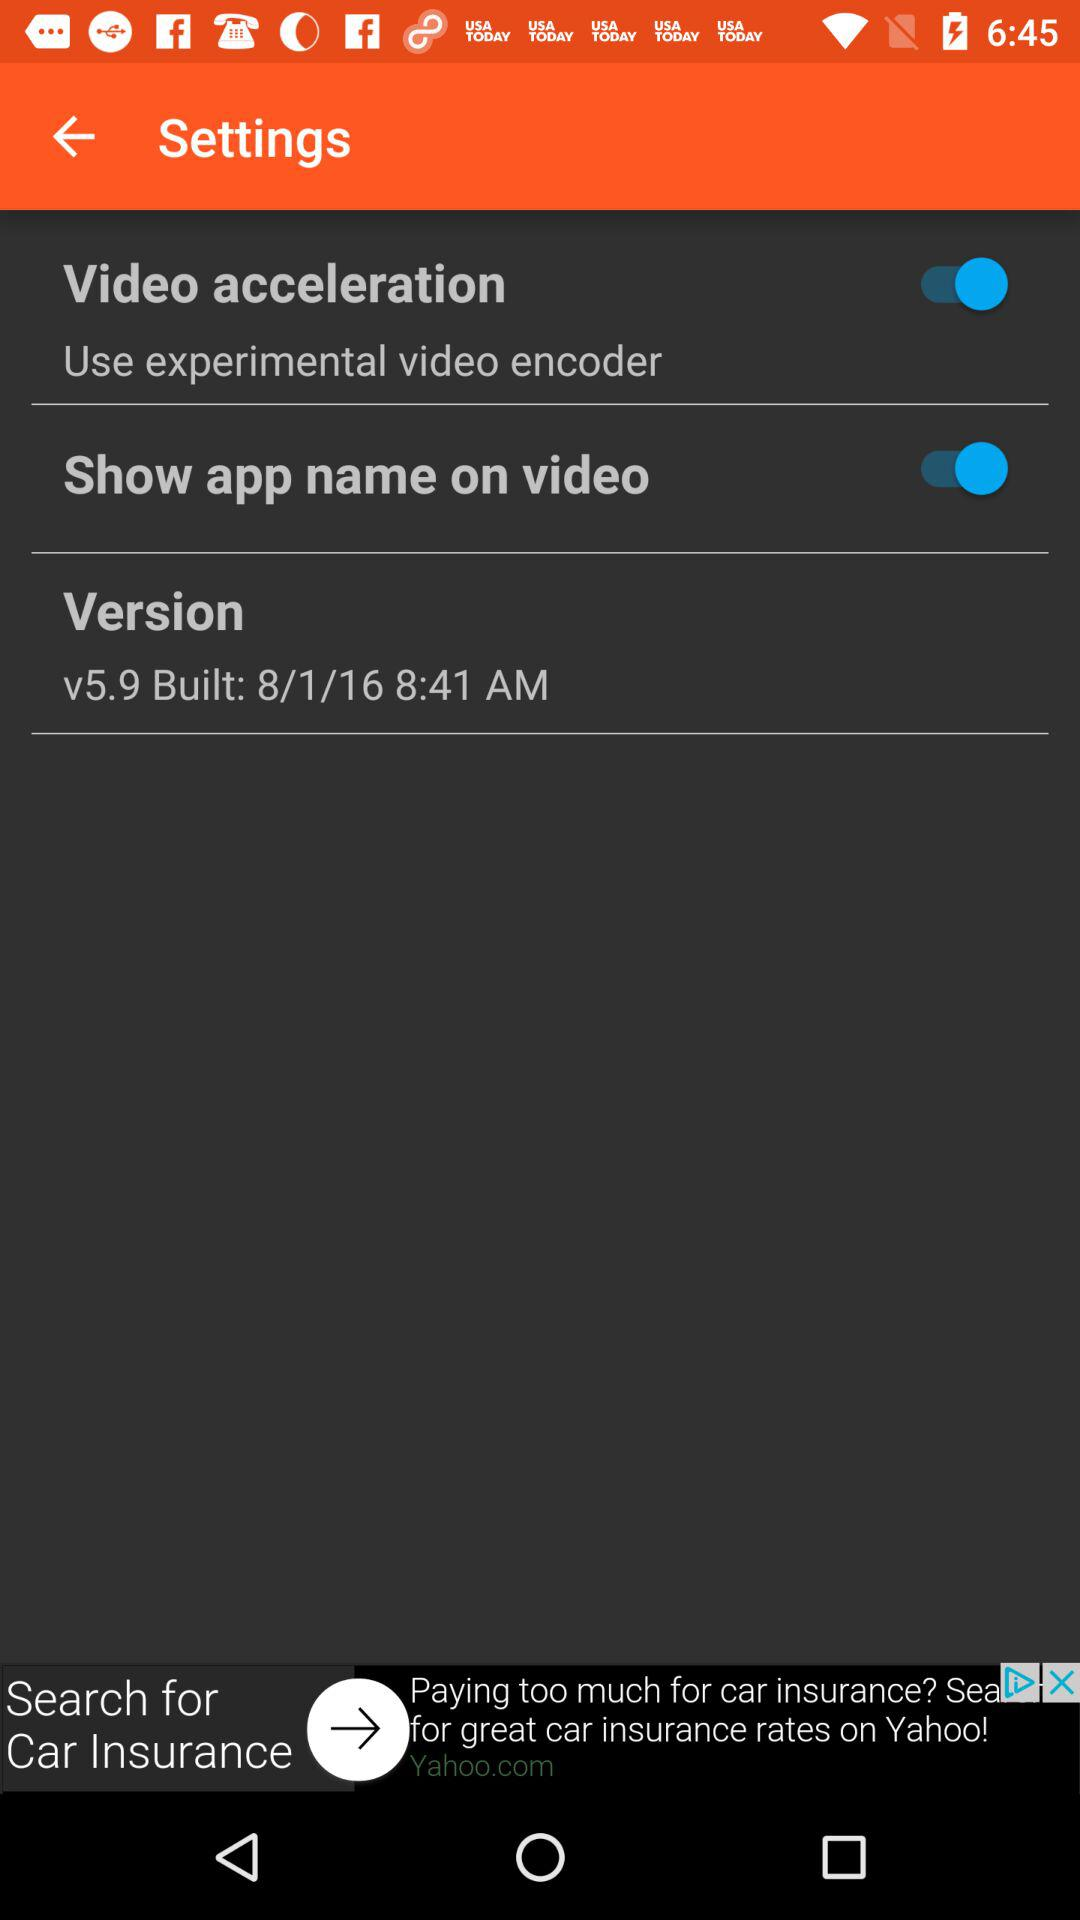Which version of the application is this? The version is 5.9. 